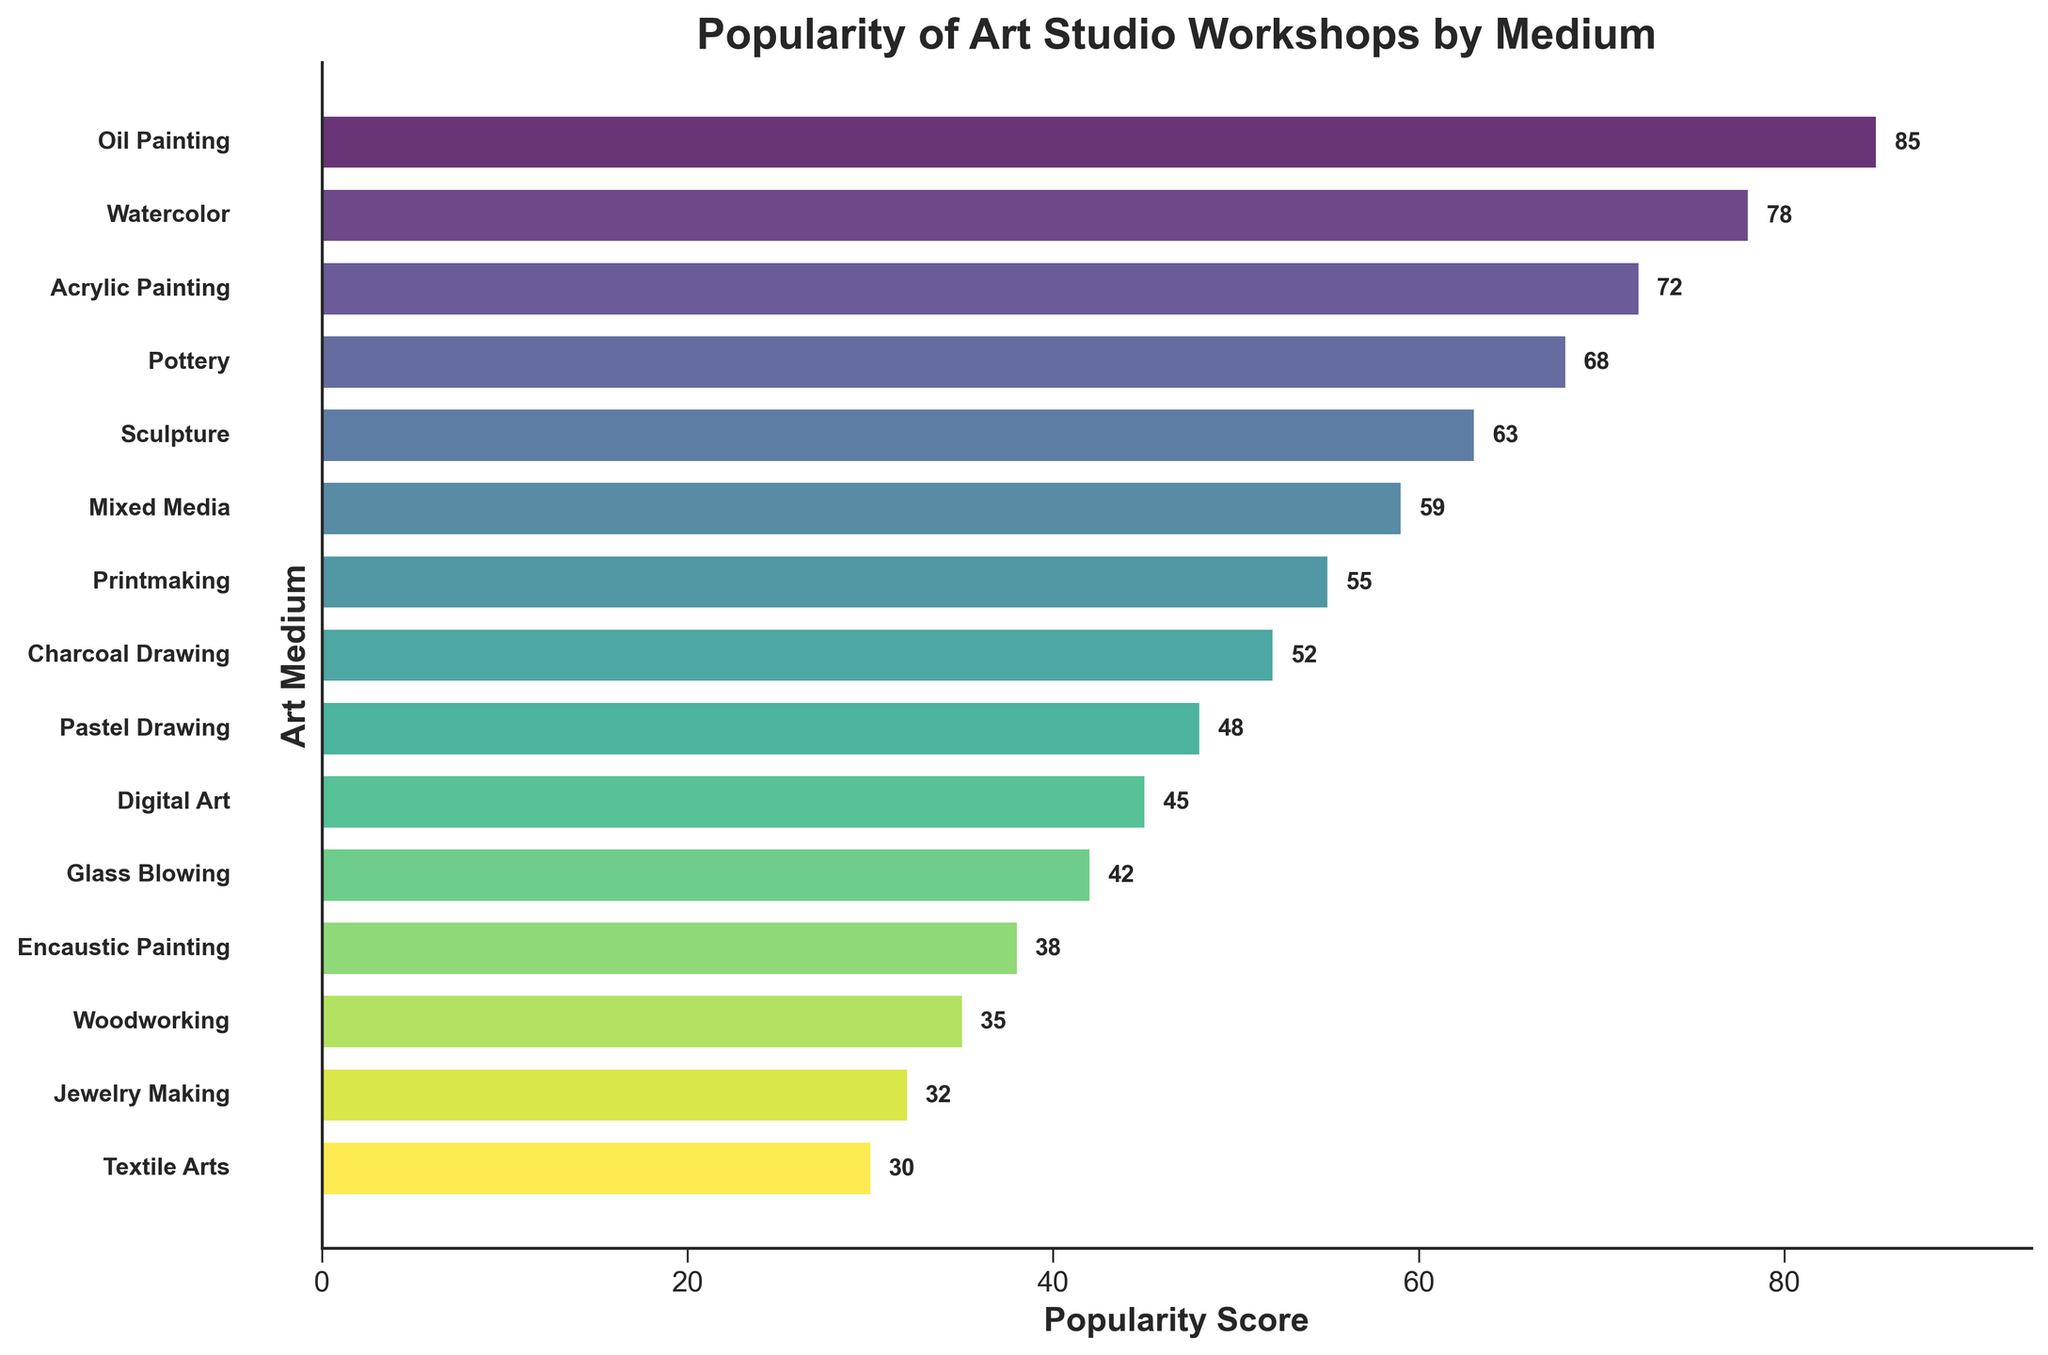What's the most popular workshop medium? The bar representing "Oil Painting" is the longest, indicating it has the highest popularity score.
Answer: Oil Painting Which workshop medium has the lowest popularity score? The shortest bar corresponds to "Textile Arts", showing it has the lowest popularity score.
Answer: Textile Arts How many mediums have a popularity score above 60? Count the bars whose lengths extend beyond the 60 mark. They are Oil Painting, Watercolor, Acrylic Painting, Pottery, and Sculpture.
Answer: 5 Which medium is more popular: Digital Art or Mixed Media? By comparing the relative lengths of the bars for Digital Art and Mixed Media, Mixed Media has a longer bar.
Answer: Mixed Media What's the popularity score difference between Printmaking and Charcoal Drawing workshops? The bar for Printmaking has a score of 55 and Charcoal Drawing has a score of 52, so the difference is 55 - 52.
Answer: 3 What's the average popularity score of Acrylic Painting, Pottery, and Sculpture? Add the scores for these mediums (72 for Acrylic Painting, 68 for Pottery, and 63 for Sculpture), then divide by 3. (72 + 68 + 63) / 3 = 67.67.
Answer: 67.67 Is Pastel Drawing more or less popular than Charcoal Drawing? Compare the lengths of the bar for Pastel Drawing and Charcoal Drawing. Charcoal Drawing has a longer bar.
Answer: Less Which medium has a popularity score closest to 50? The bar for Charcoal Drawing is the only one with a score close to 50.
Answer: Charcoal Drawing What's the sum of popularity scores for the least popular three mediums? Add the scores for Textile Arts, Jewelry Making, and Woodworking: 30 + 32 + 35.
Answer: 97 Rank the top 3 mediums by their popularity score. Identify and order the three longest bars: Oil Painting, Watercolor, and Acrylic Painting.
Answer: Oil Painting, Watercolor, Acrylic Painting 